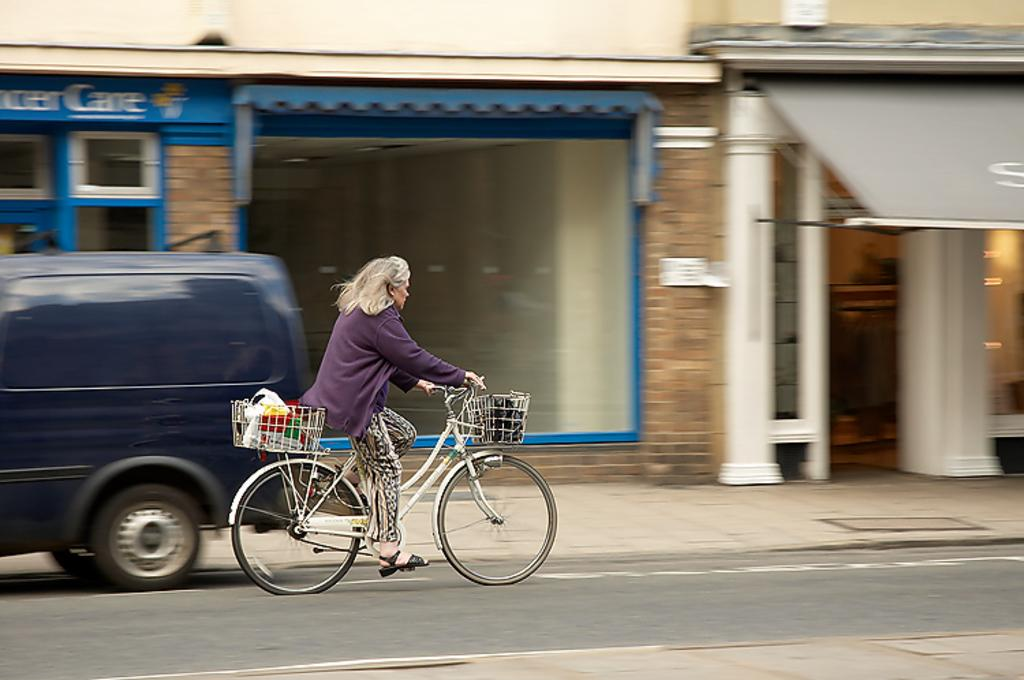What is the person in the image doing? The person in the image is riding a bicycle. What type of path is the person riding on? There is a road in the image, which the person is likely riding on. What else can be seen in the image besides the person on the bicycle? There is a vehicle, a building, and a wall in the image. What type of animals can be seen at the zoo in the image? There is no zoo present in the image, so it is not possible to determine what type of animals might be seen there. 